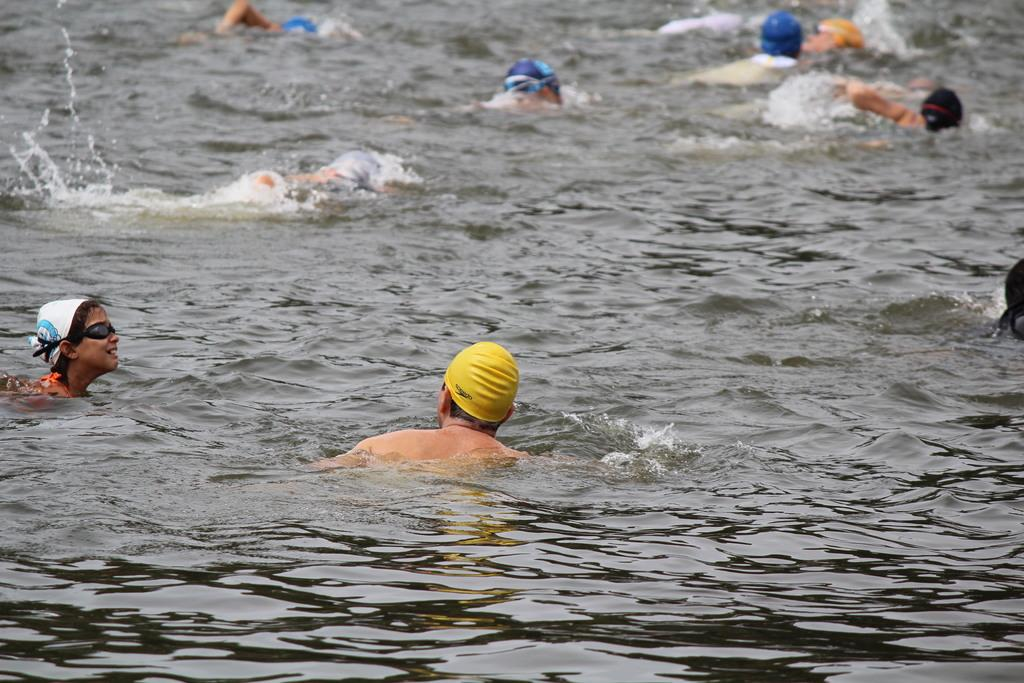What is the main subject of the image? The main subject of the image is a group of boys. What are the boys doing in the image? The boys are swimming in the lake water. What can be seen on the boys' heads in the image? The boys are wearing yellow and white color caps. What type of park can be seen in the background of the image? There is no park visible in the background of the image. What organization is responsible for the boys' swimming activity in the image? The image does not provide information about any organization involved in the boys' swimming activity. 